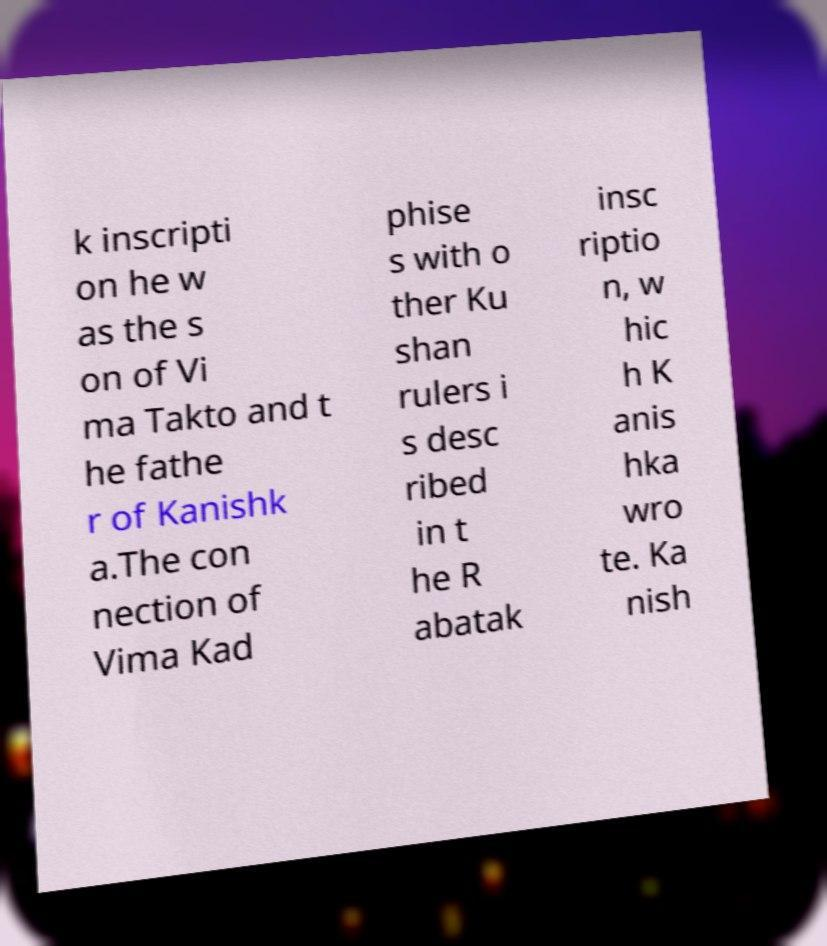Please identify and transcribe the text found in this image. k inscripti on he w as the s on of Vi ma Takto and t he fathe r of Kanishk a.The con nection of Vima Kad phise s with o ther Ku shan rulers i s desc ribed in t he R abatak insc riptio n, w hic h K anis hka wro te. Ka nish 